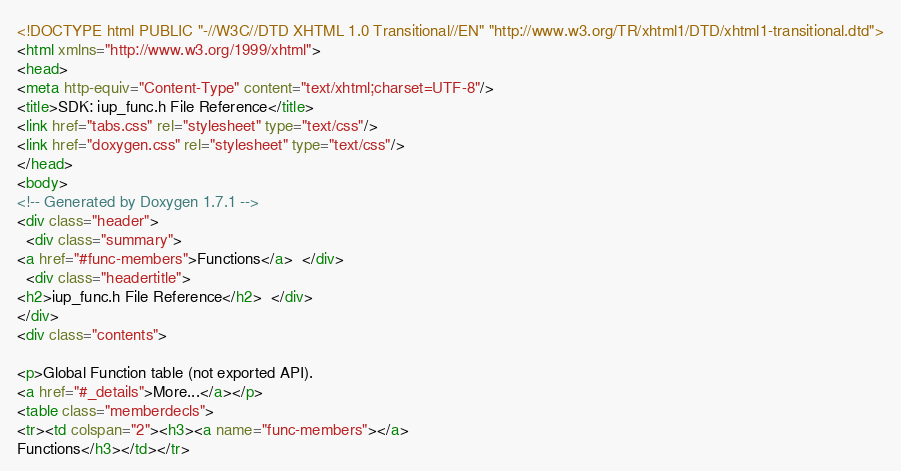<code> <loc_0><loc_0><loc_500><loc_500><_HTML_><!DOCTYPE html PUBLIC "-//W3C//DTD XHTML 1.0 Transitional//EN" "http://www.w3.org/TR/xhtml1/DTD/xhtml1-transitional.dtd">
<html xmlns="http://www.w3.org/1999/xhtml">
<head>
<meta http-equiv="Content-Type" content="text/xhtml;charset=UTF-8"/>
<title>SDK: iup_func.h File Reference</title>
<link href="tabs.css" rel="stylesheet" type="text/css"/>
<link href="doxygen.css" rel="stylesheet" type="text/css"/>
</head>
<body>
<!-- Generated by Doxygen 1.7.1 -->
<div class="header">
  <div class="summary">
<a href="#func-members">Functions</a>  </div>
  <div class="headertitle">
<h2>iup_func.h File Reference</h2>  </div>
</div>
<div class="contents">

<p>Global Function table (not exported API).  
<a href="#_details">More...</a></p>
<table class="memberdecls">
<tr><td colspan="2"><h3><a name="func-members"></a>
Functions</h3></td></tr></code> 